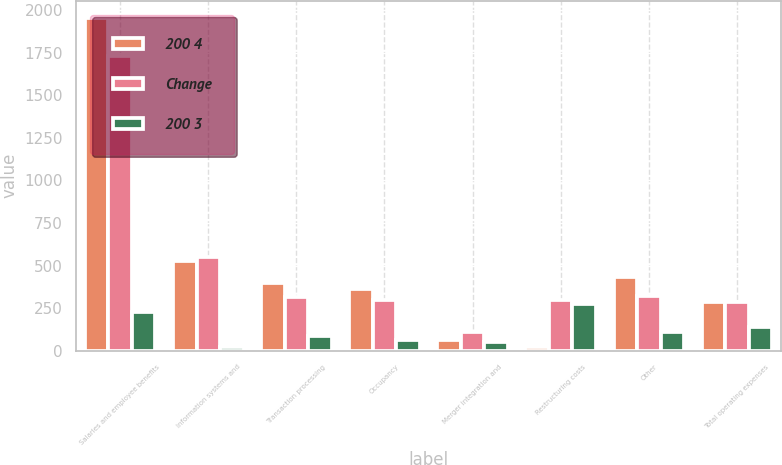<chart> <loc_0><loc_0><loc_500><loc_500><stacked_bar_chart><ecel><fcel>Salaries and employee benefits<fcel>Information systems and<fcel>Transaction processing<fcel>Occupancy<fcel>Merger integration and<fcel>Restructuring costs<fcel>Other<fcel>Total operating expenses<nl><fcel>200 4<fcel>1957<fcel>527<fcel>398<fcel>363<fcel>62<fcel>21<fcel>431<fcel>285.5<nl><fcel>Change<fcel>1731<fcel>551<fcel>314<fcel>300<fcel>110<fcel>296<fcel>320<fcel>285.5<nl><fcel>200 3<fcel>226<fcel>24<fcel>84<fcel>63<fcel>48<fcel>275<fcel>111<fcel>137<nl></chart> 